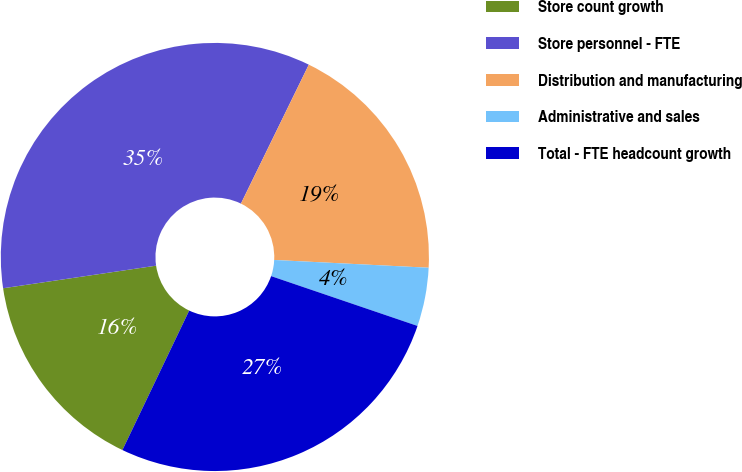<chart> <loc_0><loc_0><loc_500><loc_500><pie_chart><fcel>Store count growth<fcel>Store personnel - FTE<fcel>Distribution and manufacturing<fcel>Administrative and sales<fcel>Total - FTE headcount growth<nl><fcel>15.56%<fcel>34.57%<fcel>18.57%<fcel>4.42%<fcel>26.89%<nl></chart> 